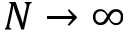Convert formula to latex. <formula><loc_0><loc_0><loc_500><loc_500>N \rightarrow \infty</formula> 